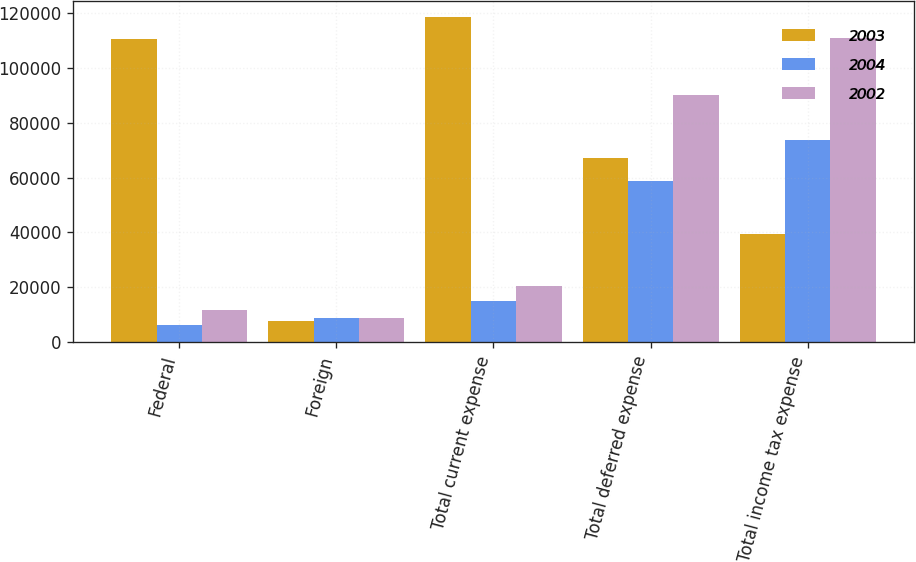<chart> <loc_0><loc_0><loc_500><loc_500><stacked_bar_chart><ecel><fcel>Federal<fcel>Foreign<fcel>Total current expense<fcel>Total deferred expense<fcel>Total income tax expense<nl><fcel>2003<fcel>110516<fcel>7748<fcel>118264<fcel>67104<fcel>39577<nl><fcel>2004<fcel>6335<fcel>8814<fcel>15149<fcel>58556<fcel>73705<nl><fcel>2002<fcel>11688<fcel>8910<fcel>20598<fcel>90059<fcel>110657<nl></chart> 